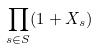<formula> <loc_0><loc_0><loc_500><loc_500>\prod _ { s \in S } ( 1 + X _ { s } )</formula> 